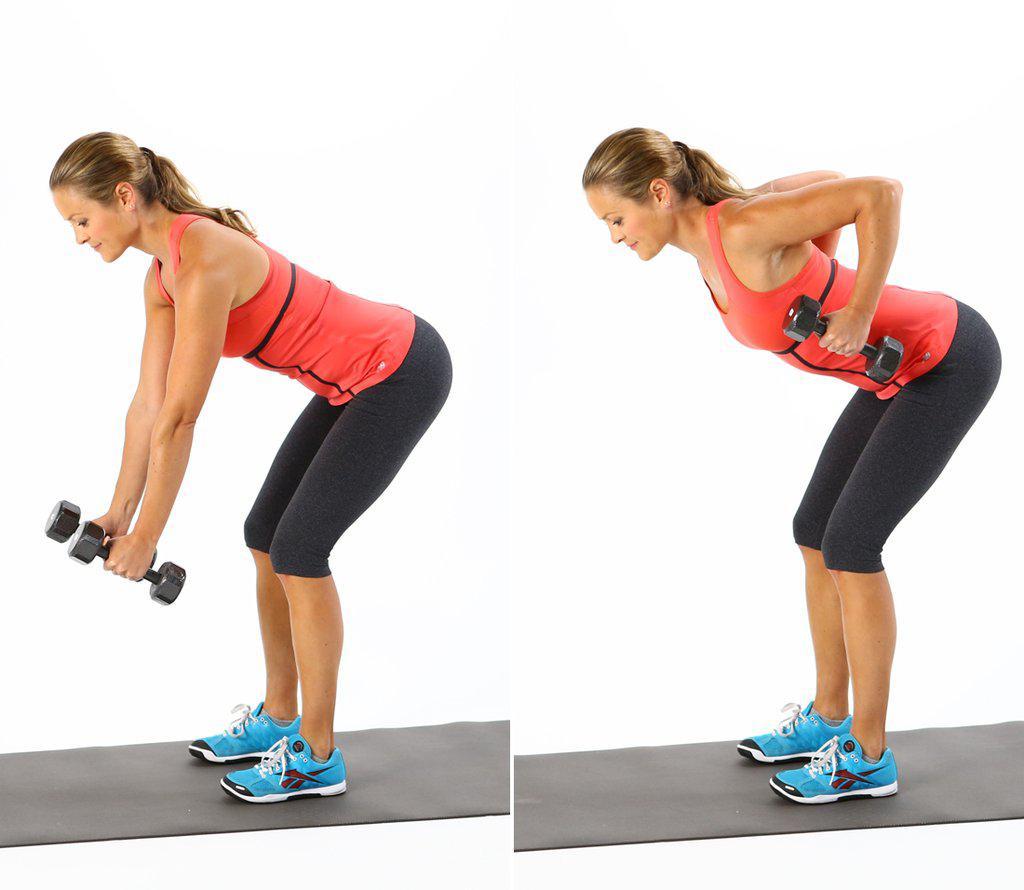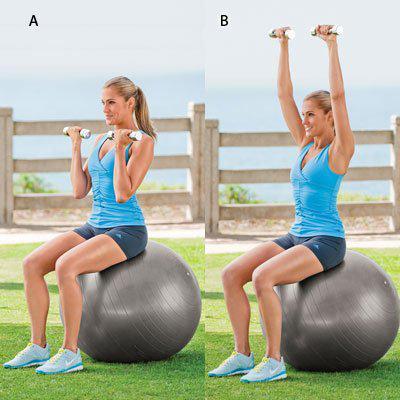The first image is the image on the left, the second image is the image on the right. For the images displayed, is the sentence "In one of the images, someone is exercising, and in the other image, people are posing." factually correct? Answer yes or no. No. 